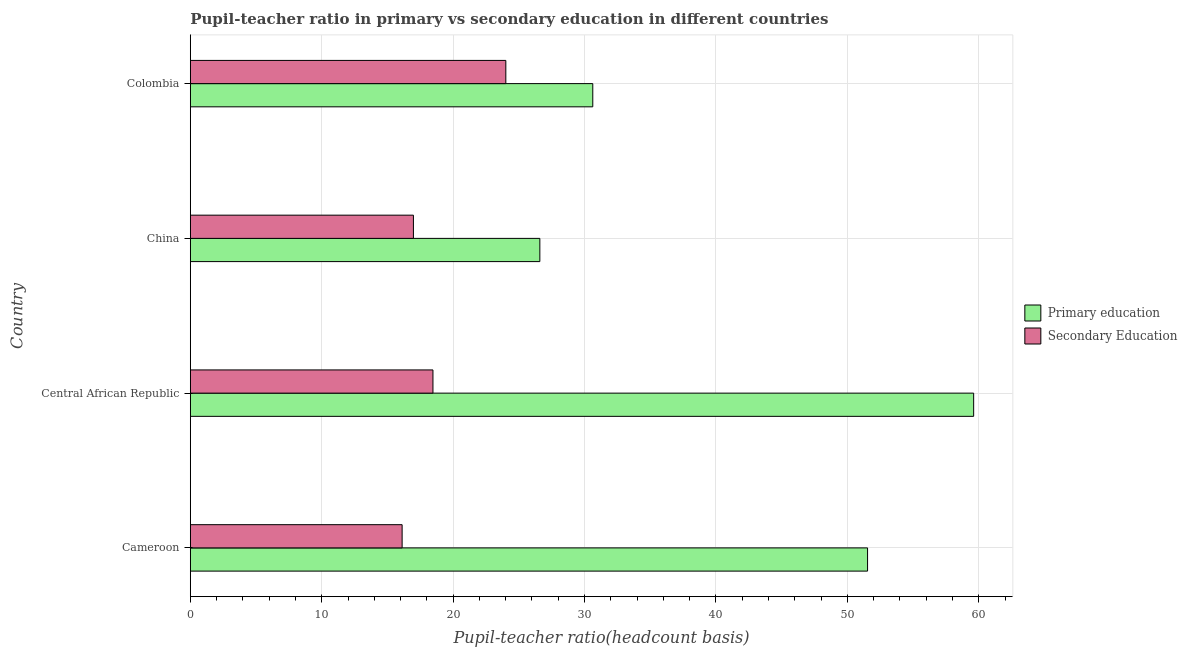Are the number of bars on each tick of the Y-axis equal?
Keep it short and to the point. Yes. How many bars are there on the 2nd tick from the bottom?
Ensure brevity in your answer.  2. What is the pupil-teacher ratio in primary education in Cameroon?
Your answer should be very brief. 51.53. Across all countries, what is the maximum pupil-teacher ratio in primary education?
Provide a succinct answer. 59.61. Across all countries, what is the minimum pupil teacher ratio on secondary education?
Keep it short and to the point. 16.12. In which country was the pupil teacher ratio on secondary education minimum?
Your answer should be very brief. Cameroon. What is the total pupil teacher ratio on secondary education in the graph?
Ensure brevity in your answer.  75.57. What is the difference between the pupil teacher ratio on secondary education in Cameroon and that in Central African Republic?
Ensure brevity in your answer.  -2.35. What is the difference between the pupil-teacher ratio in primary education in Cameroon and the pupil teacher ratio on secondary education in China?
Ensure brevity in your answer.  34.56. What is the average pupil teacher ratio on secondary education per country?
Ensure brevity in your answer.  18.89. What is the difference between the pupil teacher ratio on secondary education and pupil-teacher ratio in primary education in Colombia?
Ensure brevity in your answer.  -6.62. What is the ratio of the pupil teacher ratio on secondary education in Central African Republic to that in China?
Your response must be concise. 1.09. Is the pupil teacher ratio on secondary education in Cameroon less than that in China?
Your response must be concise. Yes. What is the difference between the highest and the second highest pupil-teacher ratio in primary education?
Your response must be concise. 8.07. What is the difference between the highest and the lowest pupil-teacher ratio in primary education?
Make the answer very short. 33.01. What does the 2nd bar from the top in Colombia represents?
Offer a very short reply. Primary education. What does the 2nd bar from the bottom in Cameroon represents?
Provide a succinct answer. Secondary Education. How many bars are there?
Give a very brief answer. 8. Are all the bars in the graph horizontal?
Your answer should be very brief. Yes. Does the graph contain grids?
Your response must be concise. Yes. How many legend labels are there?
Ensure brevity in your answer.  2. How are the legend labels stacked?
Give a very brief answer. Vertical. What is the title of the graph?
Your answer should be compact. Pupil-teacher ratio in primary vs secondary education in different countries. Does "Revenue" appear as one of the legend labels in the graph?
Offer a very short reply. No. What is the label or title of the X-axis?
Ensure brevity in your answer.  Pupil-teacher ratio(headcount basis). What is the label or title of the Y-axis?
Your answer should be very brief. Country. What is the Pupil-teacher ratio(headcount basis) of Primary education in Cameroon?
Make the answer very short. 51.53. What is the Pupil-teacher ratio(headcount basis) in Secondary Education in Cameroon?
Your response must be concise. 16.12. What is the Pupil-teacher ratio(headcount basis) of Primary education in Central African Republic?
Your response must be concise. 59.61. What is the Pupil-teacher ratio(headcount basis) of Secondary Education in Central African Republic?
Offer a terse response. 18.46. What is the Pupil-teacher ratio(headcount basis) of Primary education in China?
Provide a short and direct response. 26.6. What is the Pupil-teacher ratio(headcount basis) in Secondary Education in China?
Provide a succinct answer. 16.98. What is the Pupil-teacher ratio(headcount basis) of Primary education in Colombia?
Your answer should be compact. 30.63. What is the Pupil-teacher ratio(headcount basis) of Secondary Education in Colombia?
Your response must be concise. 24.01. Across all countries, what is the maximum Pupil-teacher ratio(headcount basis) in Primary education?
Your answer should be very brief. 59.61. Across all countries, what is the maximum Pupil-teacher ratio(headcount basis) of Secondary Education?
Offer a very short reply. 24.01. Across all countries, what is the minimum Pupil-teacher ratio(headcount basis) of Primary education?
Give a very brief answer. 26.6. Across all countries, what is the minimum Pupil-teacher ratio(headcount basis) of Secondary Education?
Provide a short and direct response. 16.12. What is the total Pupil-teacher ratio(headcount basis) in Primary education in the graph?
Your response must be concise. 168.36. What is the total Pupil-teacher ratio(headcount basis) of Secondary Education in the graph?
Offer a terse response. 75.57. What is the difference between the Pupil-teacher ratio(headcount basis) of Primary education in Cameroon and that in Central African Republic?
Offer a very short reply. -8.07. What is the difference between the Pupil-teacher ratio(headcount basis) of Secondary Education in Cameroon and that in Central African Republic?
Provide a succinct answer. -2.35. What is the difference between the Pupil-teacher ratio(headcount basis) in Primary education in Cameroon and that in China?
Your answer should be compact. 24.94. What is the difference between the Pupil-teacher ratio(headcount basis) in Secondary Education in Cameroon and that in China?
Keep it short and to the point. -0.86. What is the difference between the Pupil-teacher ratio(headcount basis) of Primary education in Cameroon and that in Colombia?
Offer a terse response. 20.91. What is the difference between the Pupil-teacher ratio(headcount basis) of Secondary Education in Cameroon and that in Colombia?
Your answer should be compact. -7.89. What is the difference between the Pupil-teacher ratio(headcount basis) of Primary education in Central African Republic and that in China?
Offer a terse response. 33.01. What is the difference between the Pupil-teacher ratio(headcount basis) of Secondary Education in Central African Republic and that in China?
Offer a very short reply. 1.49. What is the difference between the Pupil-teacher ratio(headcount basis) of Primary education in Central African Republic and that in Colombia?
Provide a succinct answer. 28.98. What is the difference between the Pupil-teacher ratio(headcount basis) of Secondary Education in Central African Republic and that in Colombia?
Your response must be concise. -5.55. What is the difference between the Pupil-teacher ratio(headcount basis) of Primary education in China and that in Colombia?
Keep it short and to the point. -4.03. What is the difference between the Pupil-teacher ratio(headcount basis) in Secondary Education in China and that in Colombia?
Provide a short and direct response. -7.03. What is the difference between the Pupil-teacher ratio(headcount basis) in Primary education in Cameroon and the Pupil-teacher ratio(headcount basis) in Secondary Education in Central African Republic?
Make the answer very short. 33.07. What is the difference between the Pupil-teacher ratio(headcount basis) of Primary education in Cameroon and the Pupil-teacher ratio(headcount basis) of Secondary Education in China?
Ensure brevity in your answer.  34.56. What is the difference between the Pupil-teacher ratio(headcount basis) in Primary education in Cameroon and the Pupil-teacher ratio(headcount basis) in Secondary Education in Colombia?
Ensure brevity in your answer.  27.52. What is the difference between the Pupil-teacher ratio(headcount basis) of Primary education in Central African Republic and the Pupil-teacher ratio(headcount basis) of Secondary Education in China?
Ensure brevity in your answer.  42.63. What is the difference between the Pupil-teacher ratio(headcount basis) of Primary education in Central African Republic and the Pupil-teacher ratio(headcount basis) of Secondary Education in Colombia?
Offer a terse response. 35.6. What is the difference between the Pupil-teacher ratio(headcount basis) in Primary education in China and the Pupil-teacher ratio(headcount basis) in Secondary Education in Colombia?
Keep it short and to the point. 2.59. What is the average Pupil-teacher ratio(headcount basis) in Primary education per country?
Provide a succinct answer. 42.09. What is the average Pupil-teacher ratio(headcount basis) in Secondary Education per country?
Offer a terse response. 18.89. What is the difference between the Pupil-teacher ratio(headcount basis) in Primary education and Pupil-teacher ratio(headcount basis) in Secondary Education in Cameroon?
Your answer should be compact. 35.42. What is the difference between the Pupil-teacher ratio(headcount basis) of Primary education and Pupil-teacher ratio(headcount basis) of Secondary Education in Central African Republic?
Ensure brevity in your answer.  41.14. What is the difference between the Pupil-teacher ratio(headcount basis) of Primary education and Pupil-teacher ratio(headcount basis) of Secondary Education in China?
Ensure brevity in your answer.  9.62. What is the difference between the Pupil-teacher ratio(headcount basis) of Primary education and Pupil-teacher ratio(headcount basis) of Secondary Education in Colombia?
Your response must be concise. 6.62. What is the ratio of the Pupil-teacher ratio(headcount basis) in Primary education in Cameroon to that in Central African Republic?
Ensure brevity in your answer.  0.86. What is the ratio of the Pupil-teacher ratio(headcount basis) in Secondary Education in Cameroon to that in Central African Republic?
Offer a terse response. 0.87. What is the ratio of the Pupil-teacher ratio(headcount basis) in Primary education in Cameroon to that in China?
Provide a short and direct response. 1.94. What is the ratio of the Pupil-teacher ratio(headcount basis) in Secondary Education in Cameroon to that in China?
Keep it short and to the point. 0.95. What is the ratio of the Pupil-teacher ratio(headcount basis) of Primary education in Cameroon to that in Colombia?
Offer a terse response. 1.68. What is the ratio of the Pupil-teacher ratio(headcount basis) of Secondary Education in Cameroon to that in Colombia?
Provide a short and direct response. 0.67. What is the ratio of the Pupil-teacher ratio(headcount basis) in Primary education in Central African Republic to that in China?
Offer a very short reply. 2.24. What is the ratio of the Pupil-teacher ratio(headcount basis) in Secondary Education in Central African Republic to that in China?
Your answer should be very brief. 1.09. What is the ratio of the Pupil-teacher ratio(headcount basis) in Primary education in Central African Republic to that in Colombia?
Offer a very short reply. 1.95. What is the ratio of the Pupil-teacher ratio(headcount basis) in Secondary Education in Central African Republic to that in Colombia?
Your answer should be very brief. 0.77. What is the ratio of the Pupil-teacher ratio(headcount basis) in Primary education in China to that in Colombia?
Your response must be concise. 0.87. What is the ratio of the Pupil-teacher ratio(headcount basis) of Secondary Education in China to that in Colombia?
Provide a succinct answer. 0.71. What is the difference between the highest and the second highest Pupil-teacher ratio(headcount basis) of Primary education?
Ensure brevity in your answer.  8.07. What is the difference between the highest and the second highest Pupil-teacher ratio(headcount basis) in Secondary Education?
Offer a very short reply. 5.55. What is the difference between the highest and the lowest Pupil-teacher ratio(headcount basis) of Primary education?
Offer a terse response. 33.01. What is the difference between the highest and the lowest Pupil-teacher ratio(headcount basis) in Secondary Education?
Your answer should be very brief. 7.89. 